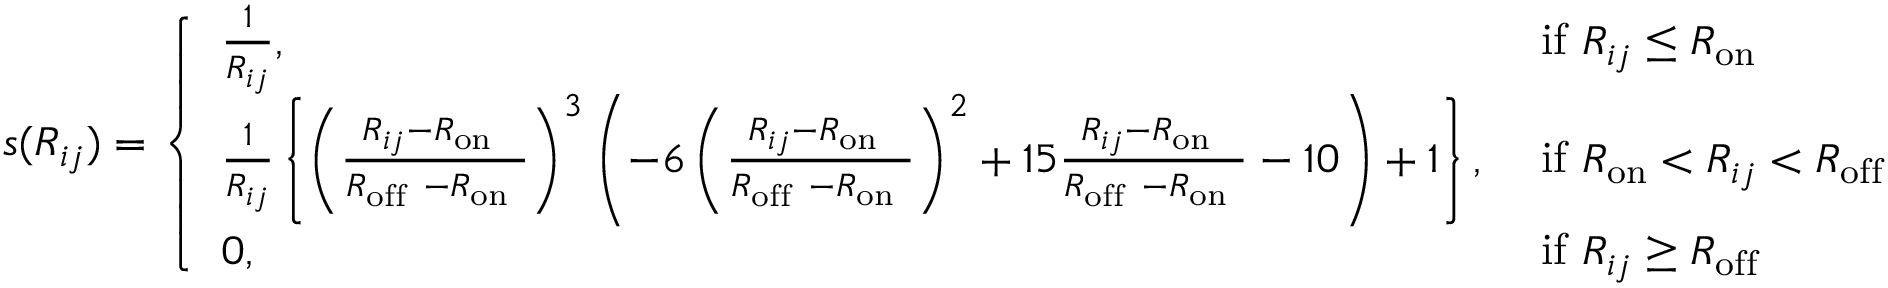<formula> <loc_0><loc_0><loc_500><loc_500>s ( R _ { i j } ) = \left \{ \begin{array} { l l } { \frac { 1 } { R _ { i j } } , } & { i f R _ { i j } \leq R _ { o n } } \\ { \frac { 1 } { R _ { i j } } \left \{ \left ( \frac { R _ { i j } - R _ { o n } } { R _ { o f f } - R _ { o n } } \right ) ^ { 3 } \left ( - 6 \left ( \frac { R _ { i j } - R _ { o n } } { R _ { o f f } - R _ { o n } } \right ) ^ { 2 } + 1 5 \frac { R _ { i j } - R _ { o n } } { R _ { o f f } - R _ { o n } } - 1 0 \right ) + 1 \right \} , } & { i f R _ { o n } < R _ { i j } < R _ { o f f } } \\ { 0 , } & { i f R _ { i j } \geq R _ { o f f } } \end{array}</formula> 